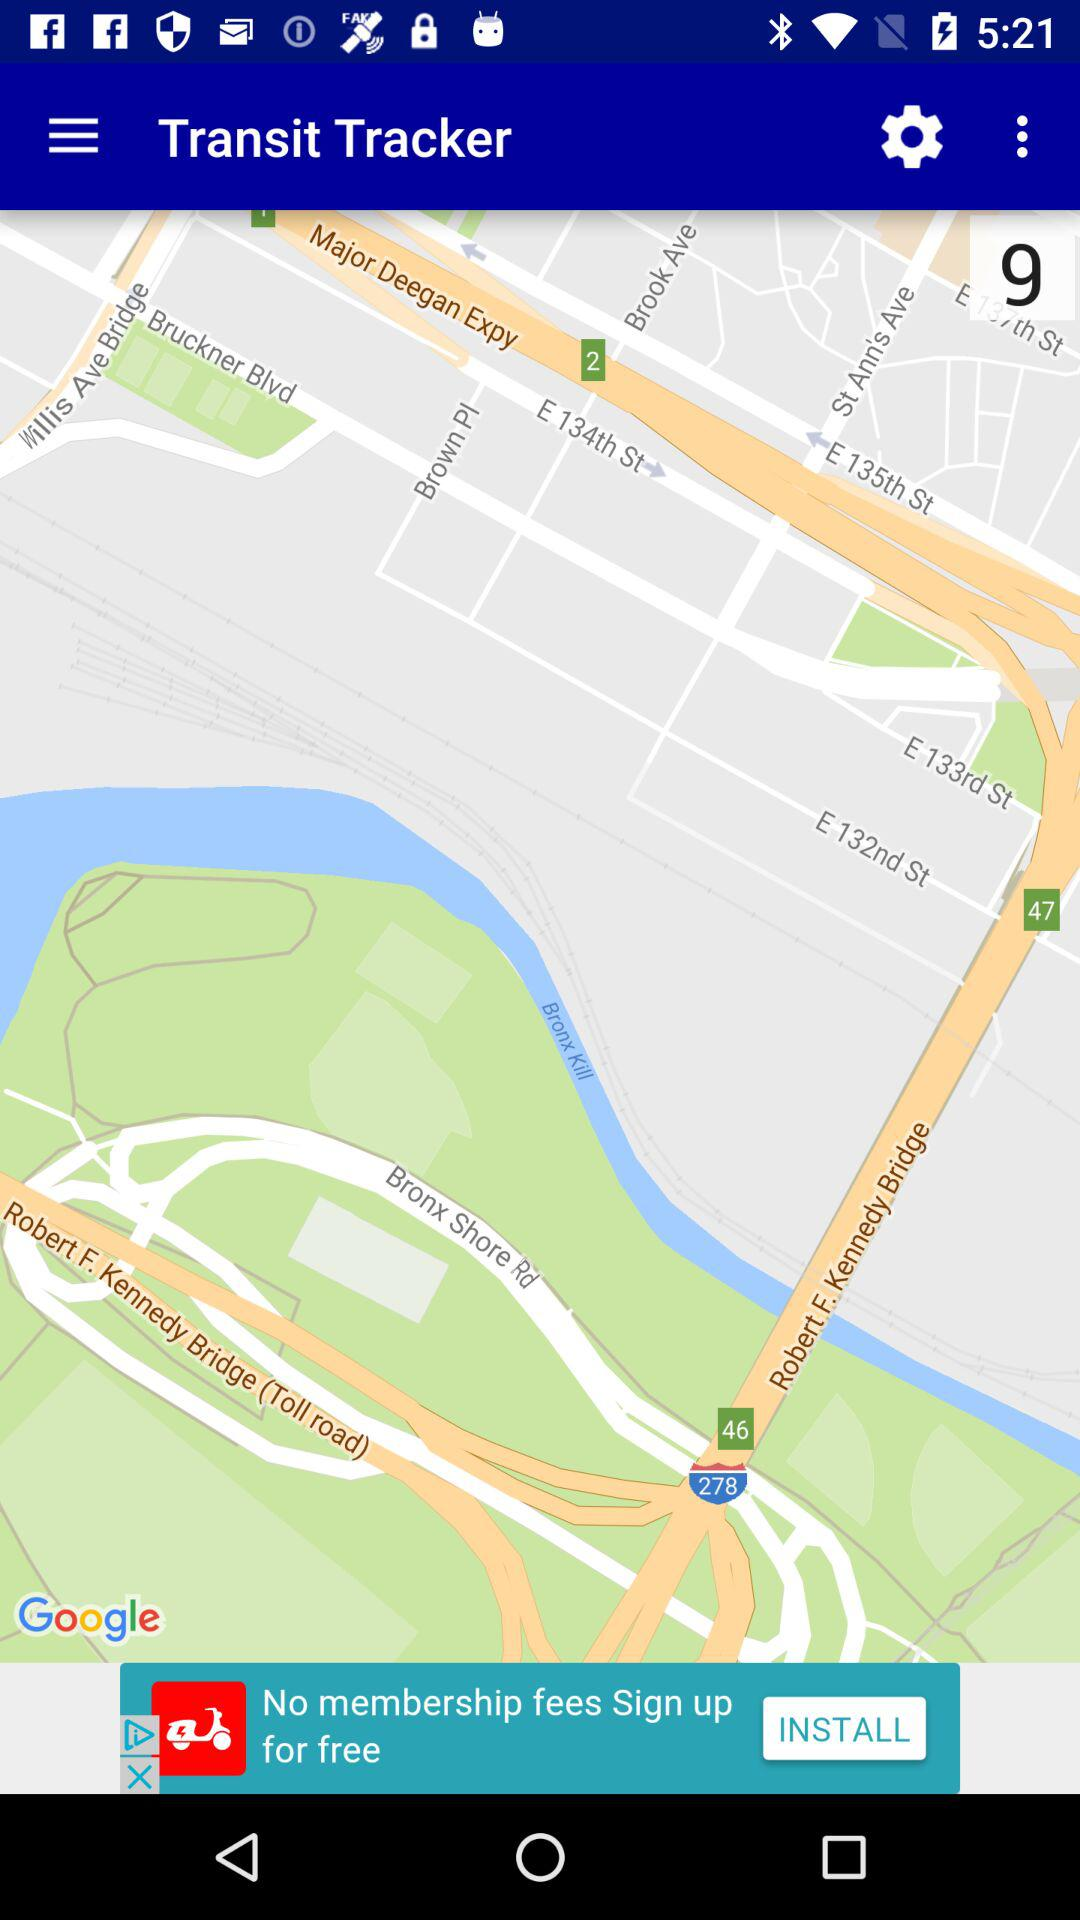Which city transit map is selected?
When the provided information is insufficient, respond with <no answer>. <no answer> 